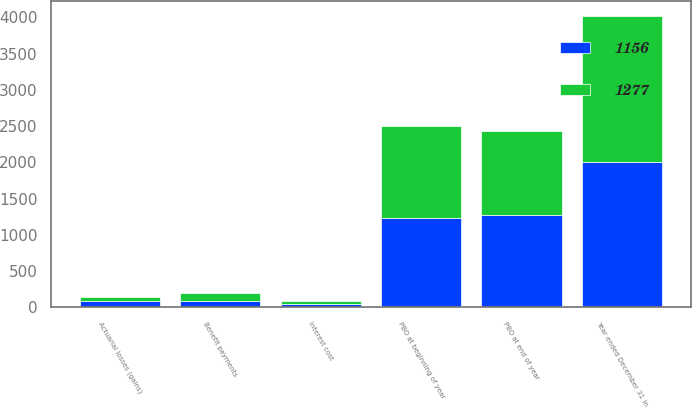<chart> <loc_0><loc_0><loc_500><loc_500><stacked_bar_chart><ecel><fcel>Year ended December 31 in<fcel>PBO at beginning of year<fcel>Interest cost<fcel>Actuarial losses (gains)<fcel>Benefit payments<fcel>PBO at end of year<nl><fcel>1277<fcel>2013<fcel>1277<fcel>42<fcel>54<fcel>109<fcel>1156<nl><fcel>1156<fcel>2012<fcel>1228<fcel>47<fcel>86<fcel>84<fcel>1277<nl></chart> 